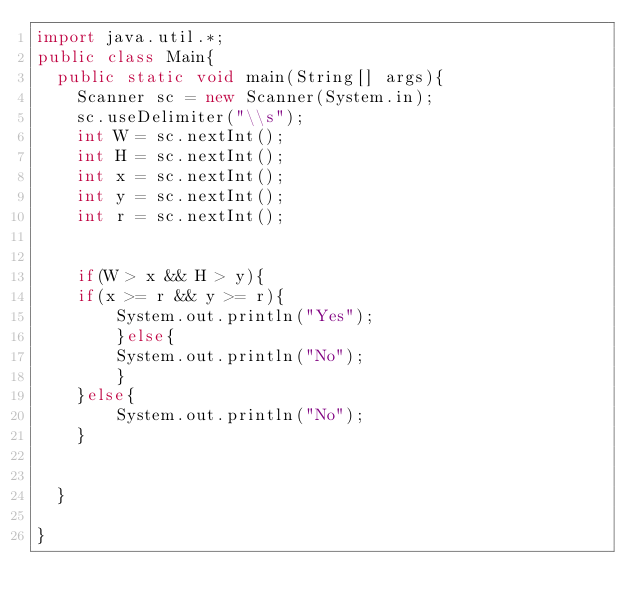Convert code to text. <code><loc_0><loc_0><loc_500><loc_500><_Java_>import java.util.*;
public class Main{
  public static void main(String[] args){
    Scanner sc = new Scanner(System.in);
    sc.useDelimiter("\\s");
    int W = sc.nextInt();
    int H = sc.nextInt();
    int x = sc.nextInt();
    int y = sc.nextInt();
    int r = sc.nextInt();


    if(W > x && H > y){
	if(x >= r && y >= r){
		System.out.println("Yes");
        }else{
		System.out.println("No");
        }
    }else{
		System.out.println("No");
    }

   
  }

}</code> 